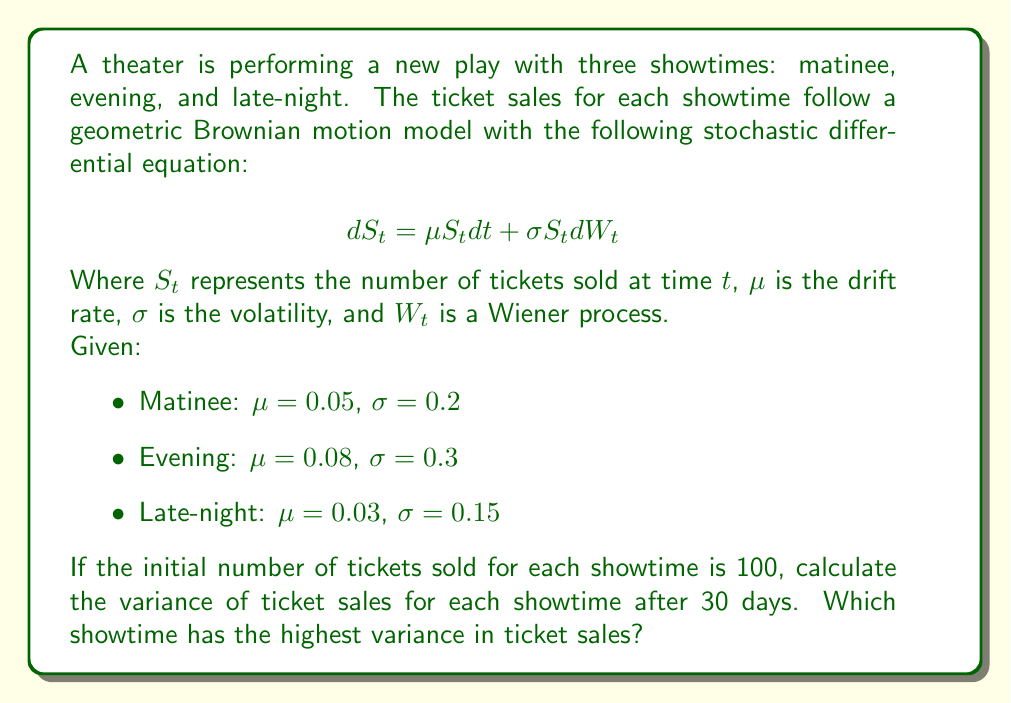Help me with this question. To solve this problem, we'll use the formula for the variance of a geometric Brownian motion:

$$Var(S_t) = S_0^2 e^{2\mu t} (e^{\sigma^2 t} - 1)$$

Where $S_0$ is the initial number of tickets sold, $t$ is the time in days, $\mu$ is the drift rate, and $\sigma$ is the volatility.

Let's calculate the variance for each showtime:

1. Matinee:
   $S_0 = 100$, $\mu = 0.05$, $\sigma = 0.2$, $t = 30$
   $$Var(S_t) = 100^2 e^{2(0.05)(30)} (e^{0.2^2(30)} - 1) = 10000 e^3 (e^{1.2} - 1) \approx 41,683.87$$

2. Evening:
   $S_0 = 100$, $\mu = 0.08$, $\sigma = 0.3$, $t = 30$
   $$Var(S_t) = 100^2 e^{2(0.08)(30)} (e^{0.3^2(30)} - 1) = 10000 e^{4.8} (e^{2.7} - 1) \approx 180,186.36$$

3. Late-night:
   $S_0 = 100$, $\mu = 0.03$, $\sigma = 0.15$, $t = 30$
   $$Var(S_t) = 100^2 e^{2(0.03)(30)} (e^{0.15^2(30)} - 1) = 10000 e^{1.8} (e^{0.675} - 1) \approx 13,404.16$$

Comparing the variances:
Matinee: 41,683.87
Evening: 180,186.36
Late-night: 13,404.16

The evening showtime has the highest variance in ticket sales.
Answer: Evening showtime; Variance ≈ 180,186.36 